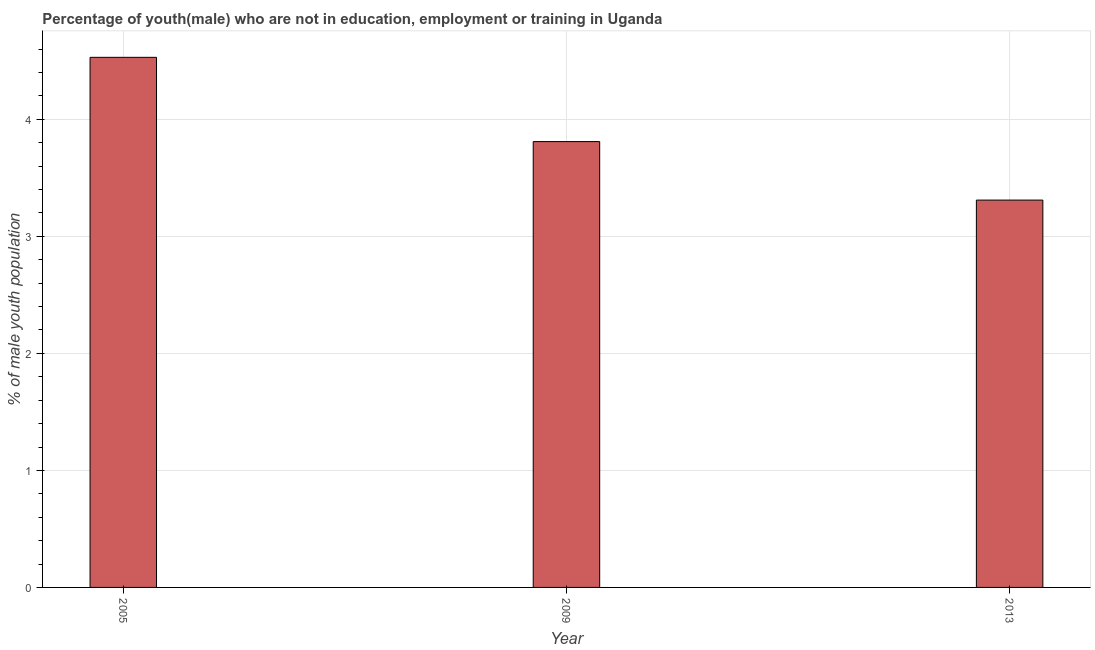Does the graph contain any zero values?
Offer a terse response. No. Does the graph contain grids?
Give a very brief answer. Yes. What is the title of the graph?
Provide a succinct answer. Percentage of youth(male) who are not in education, employment or training in Uganda. What is the label or title of the X-axis?
Offer a very short reply. Year. What is the label or title of the Y-axis?
Provide a succinct answer. % of male youth population. What is the unemployed male youth population in 2013?
Your answer should be compact. 3.31. Across all years, what is the maximum unemployed male youth population?
Ensure brevity in your answer.  4.53. Across all years, what is the minimum unemployed male youth population?
Your answer should be very brief. 3.31. In which year was the unemployed male youth population maximum?
Offer a terse response. 2005. In which year was the unemployed male youth population minimum?
Give a very brief answer. 2013. What is the sum of the unemployed male youth population?
Your response must be concise. 11.65. What is the difference between the unemployed male youth population in 2005 and 2013?
Make the answer very short. 1.22. What is the average unemployed male youth population per year?
Offer a terse response. 3.88. What is the median unemployed male youth population?
Make the answer very short. 3.81. In how many years, is the unemployed male youth population greater than 4.4 %?
Provide a short and direct response. 1. What is the ratio of the unemployed male youth population in 2005 to that in 2013?
Provide a short and direct response. 1.37. Is the difference between the unemployed male youth population in 2005 and 2009 greater than the difference between any two years?
Keep it short and to the point. No. What is the difference between the highest and the second highest unemployed male youth population?
Offer a terse response. 0.72. What is the difference between the highest and the lowest unemployed male youth population?
Provide a succinct answer. 1.22. In how many years, is the unemployed male youth population greater than the average unemployed male youth population taken over all years?
Keep it short and to the point. 1. How many bars are there?
Give a very brief answer. 3. Are all the bars in the graph horizontal?
Make the answer very short. No. How many years are there in the graph?
Your response must be concise. 3. Are the values on the major ticks of Y-axis written in scientific E-notation?
Offer a terse response. No. What is the % of male youth population of 2005?
Make the answer very short. 4.53. What is the % of male youth population in 2009?
Your answer should be compact. 3.81. What is the % of male youth population in 2013?
Your response must be concise. 3.31. What is the difference between the % of male youth population in 2005 and 2009?
Offer a terse response. 0.72. What is the difference between the % of male youth population in 2005 and 2013?
Provide a short and direct response. 1.22. What is the ratio of the % of male youth population in 2005 to that in 2009?
Make the answer very short. 1.19. What is the ratio of the % of male youth population in 2005 to that in 2013?
Offer a terse response. 1.37. What is the ratio of the % of male youth population in 2009 to that in 2013?
Your response must be concise. 1.15. 